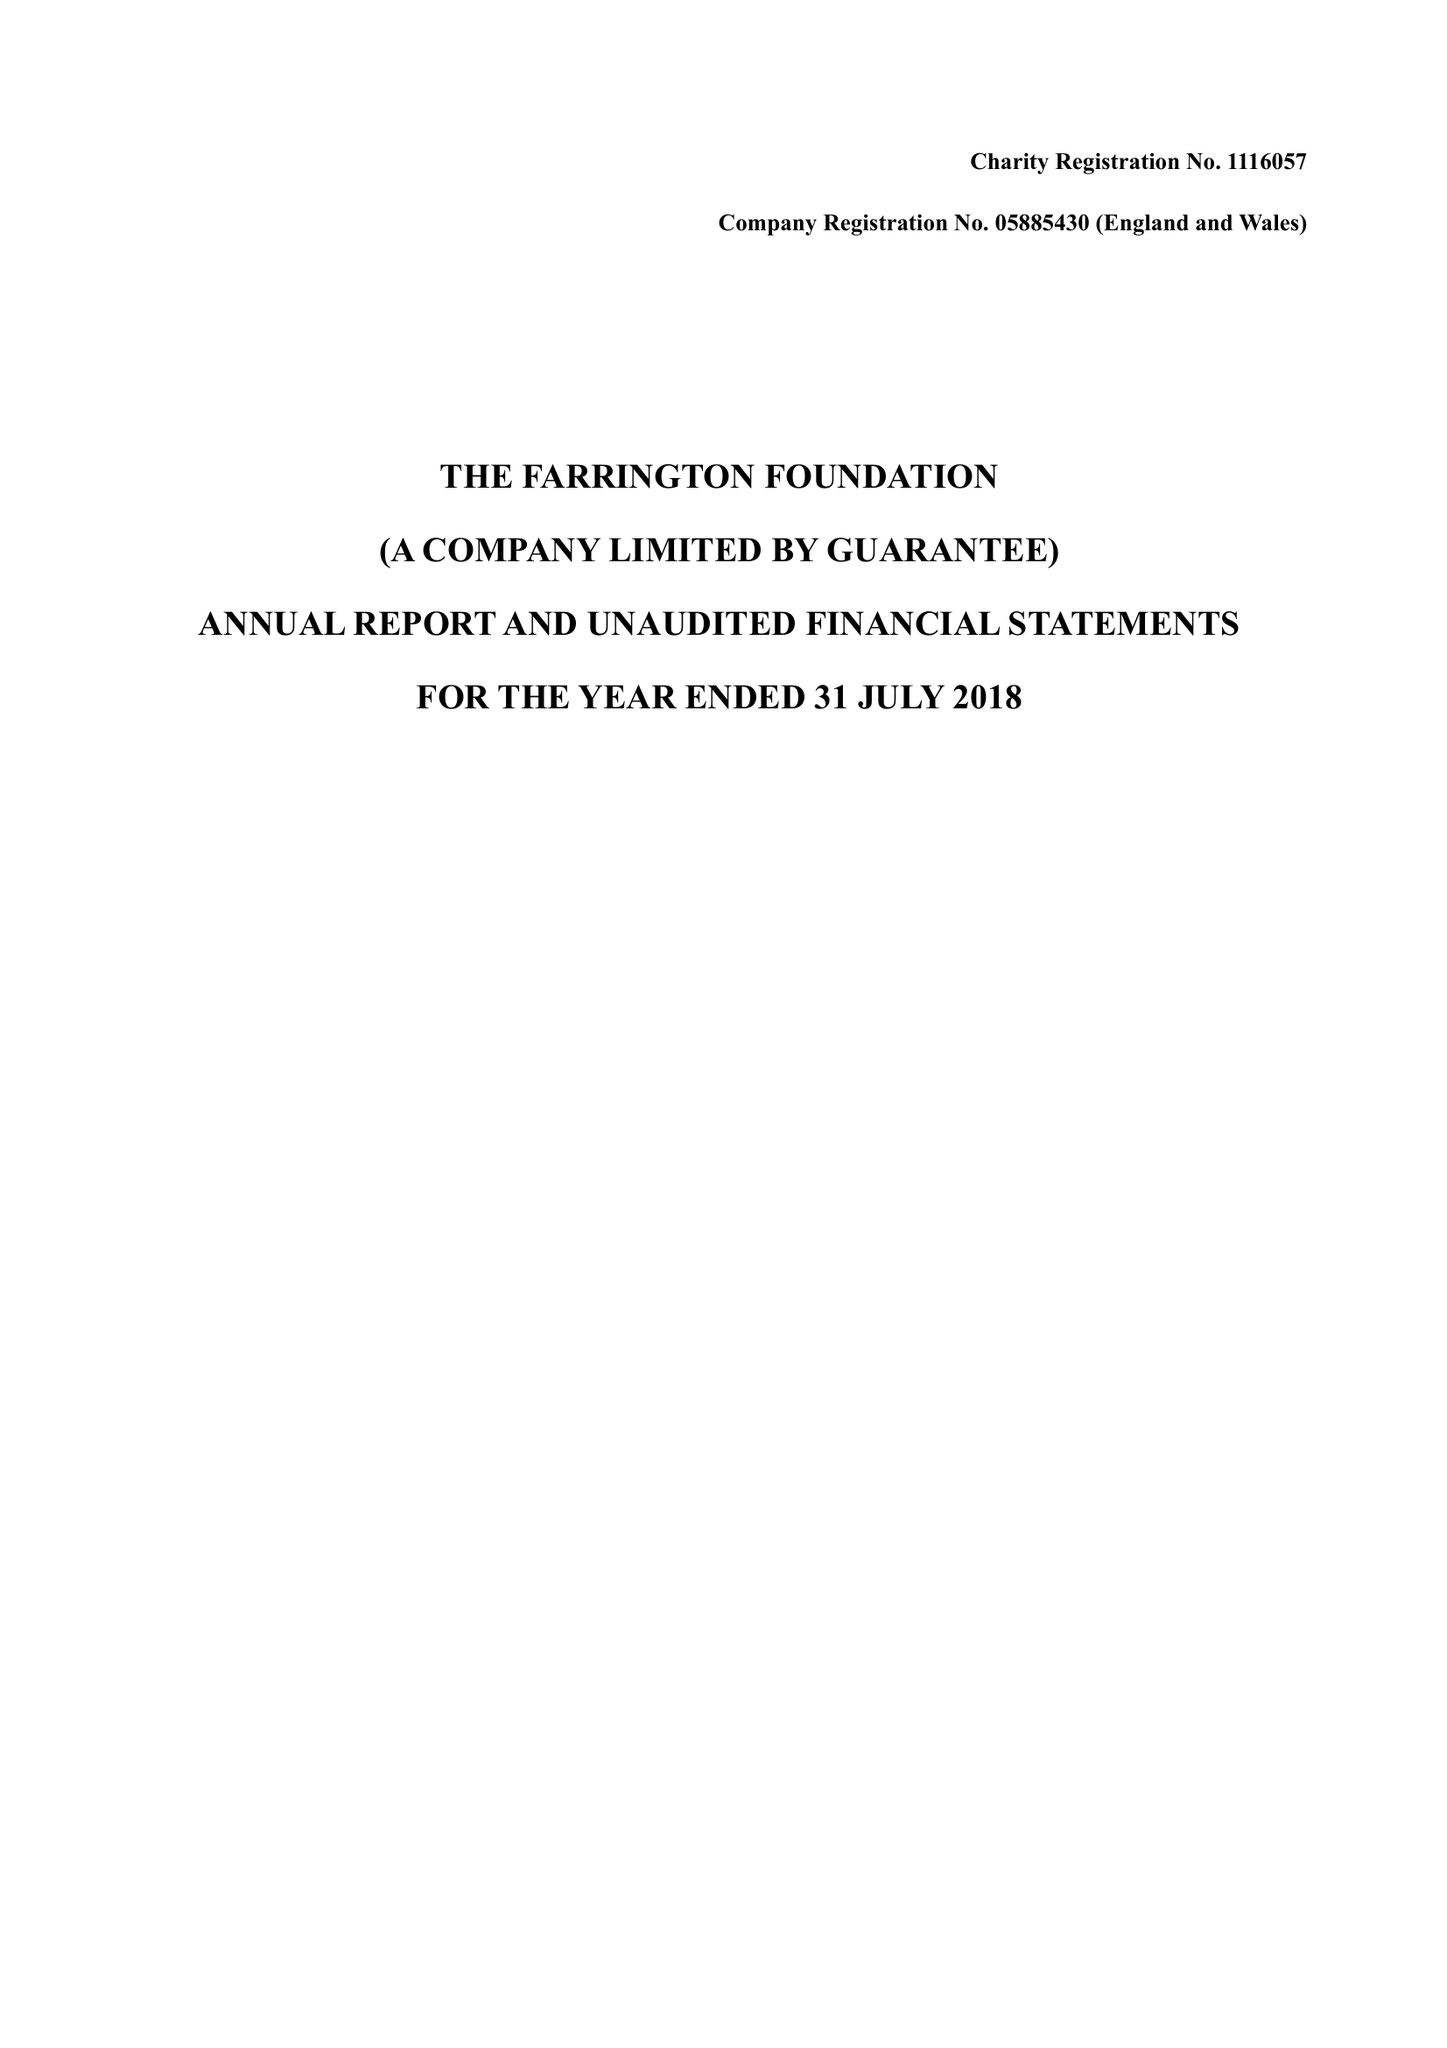What is the value for the report_date?
Answer the question using a single word or phrase. 2018-07-31 